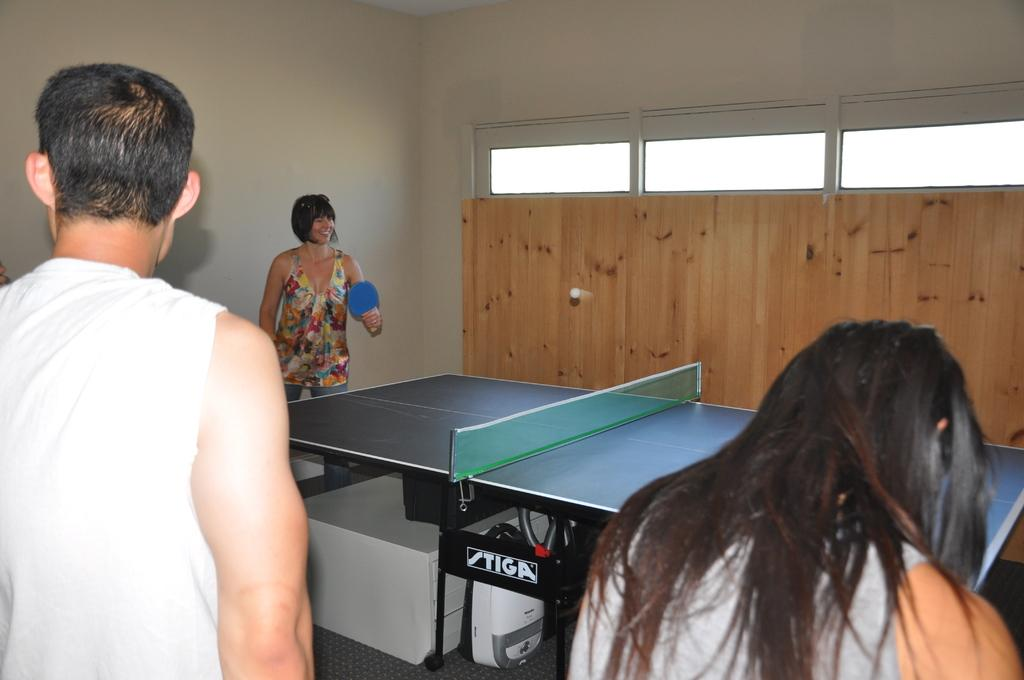What is one of the main features of the image? There is a wall in the image. What activity is the woman engaged in? The woman is standing and playing table tennis. What is beneath the people in the image? There is a floor in the image. How many people are present in the image? There are people in the image, including a woman and a man. Where are the people standing in relation to the table tennis? These people are standing near the table tennis. Can you tell me how many owls are sitting on the table tennis table in the image? There are no owls present in the image; it features a woman playing table tennis and people standing nearby. 